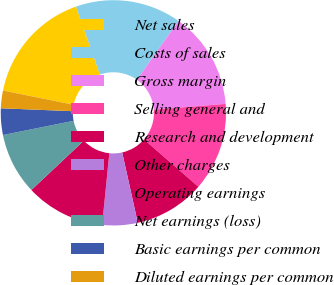Convert chart to OTSL. <chart><loc_0><loc_0><loc_500><loc_500><pie_chart><fcel>Net sales<fcel>Costs of sales<fcel>Gross margin<fcel>Selling general and<fcel>Research and development<fcel>Other charges<fcel>Operating earnings<fcel>Net earnings (loss)<fcel>Basic earnings per common<fcel>Diluted earnings per common<nl><fcel>16.45%<fcel>15.19%<fcel>13.92%<fcel>12.66%<fcel>10.13%<fcel>5.07%<fcel>11.39%<fcel>8.86%<fcel>3.8%<fcel>2.53%<nl></chart> 